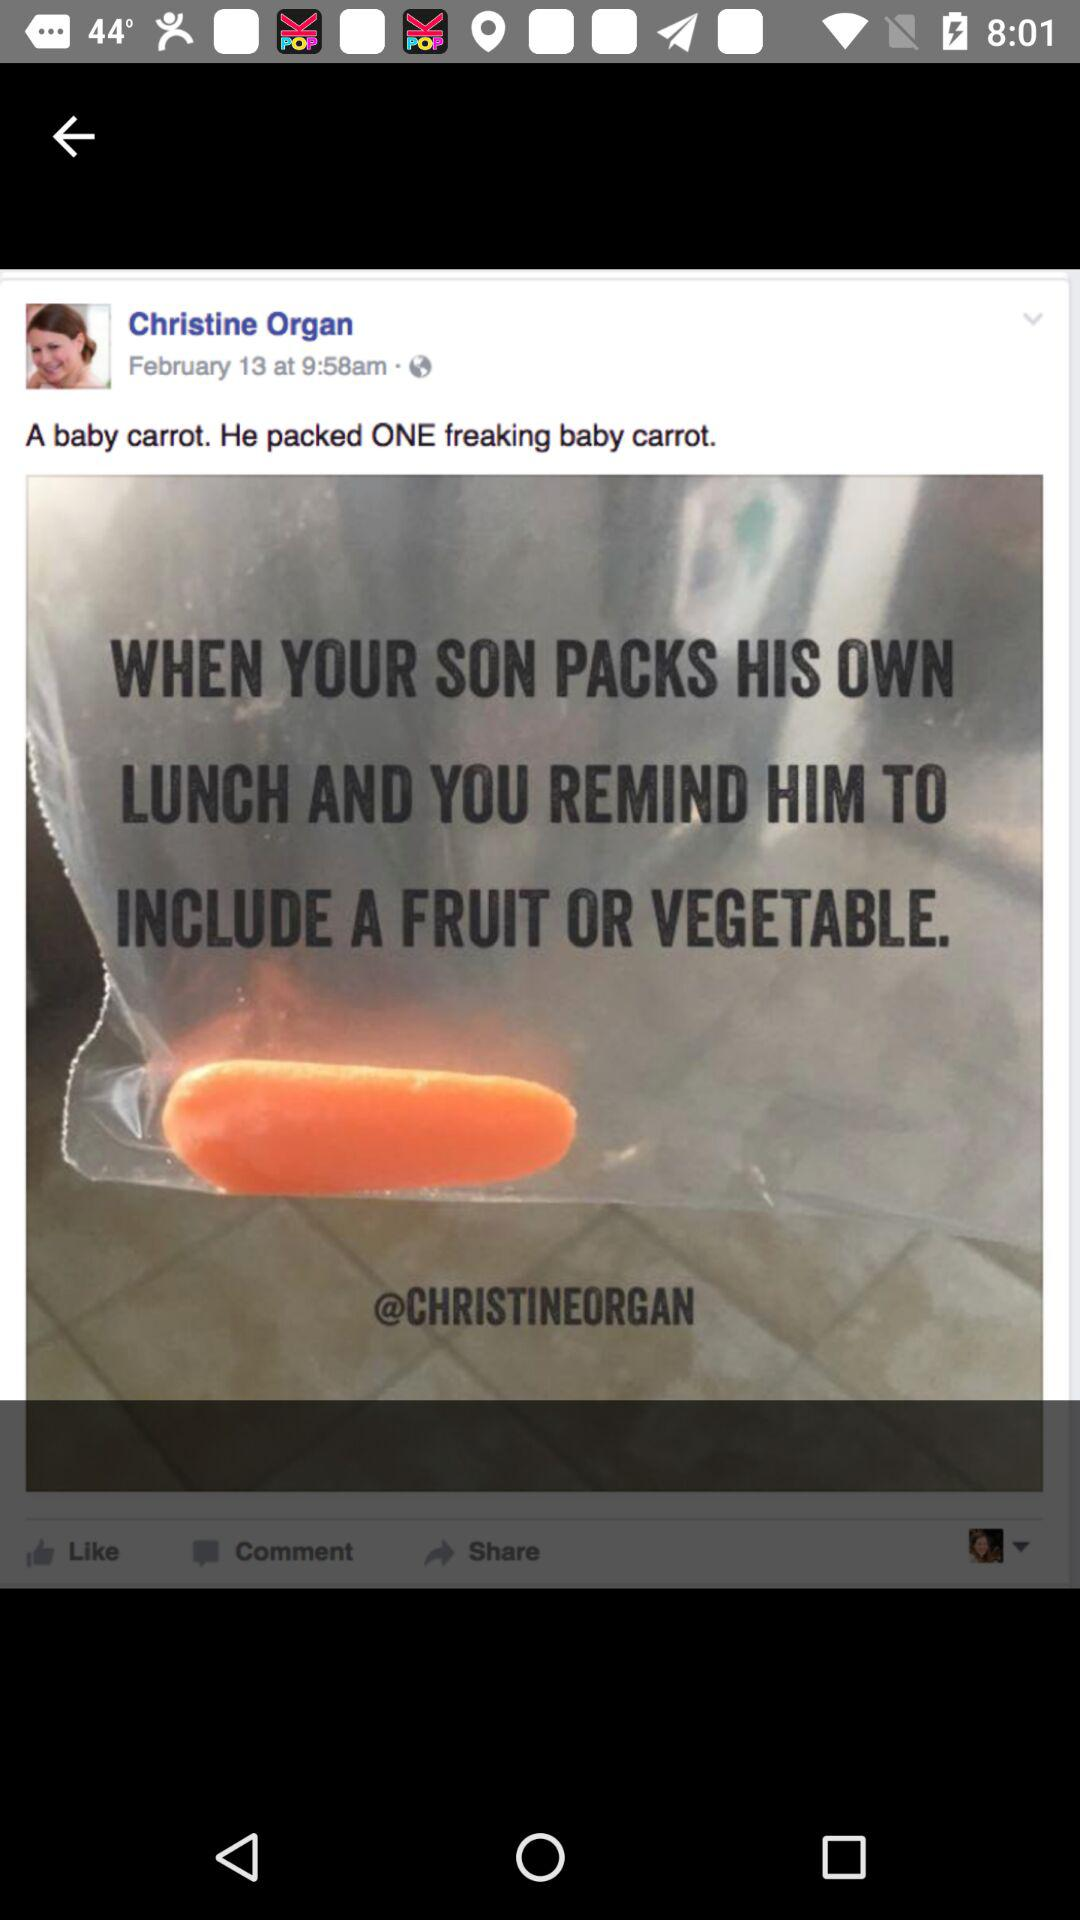What is the mentioned date and time? The mentioned date is February 13 and the time is 9:58 a.m. 